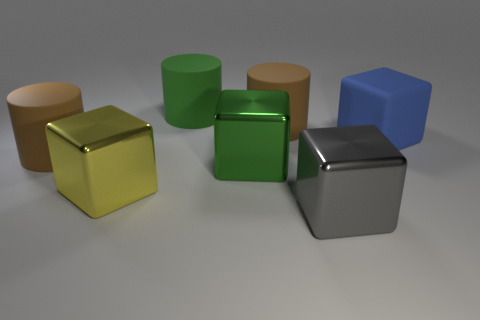The yellow thing that is the same shape as the big gray shiny thing is what size?
Keep it short and to the point. Large. Are there any other things that are the same size as the yellow cube?
Your answer should be very brief. Yes. What is the material of the large gray block that is on the right side of the rubber cylinder that is on the right side of the green matte cylinder?
Make the answer very short. Metal. Is the big blue object the same shape as the large yellow object?
Ensure brevity in your answer.  Yes. What number of large things are behind the yellow shiny cube and in front of the big green cylinder?
Provide a short and direct response. 4. Is the number of cylinders that are on the right side of the green matte object the same as the number of metallic blocks behind the large green block?
Offer a terse response. No. There is a green object that is in front of the blue cube; is its size the same as the brown matte cylinder on the right side of the large green metallic block?
Your answer should be very brief. Yes. There is a block that is both right of the large green block and behind the gray metallic thing; what is its material?
Make the answer very short. Rubber. Is the number of large green things less than the number of green rubber cylinders?
Ensure brevity in your answer.  No. There is a metal thing that is on the right side of the large brown rubber object that is behind the blue cube; what is its size?
Your response must be concise. Large. 